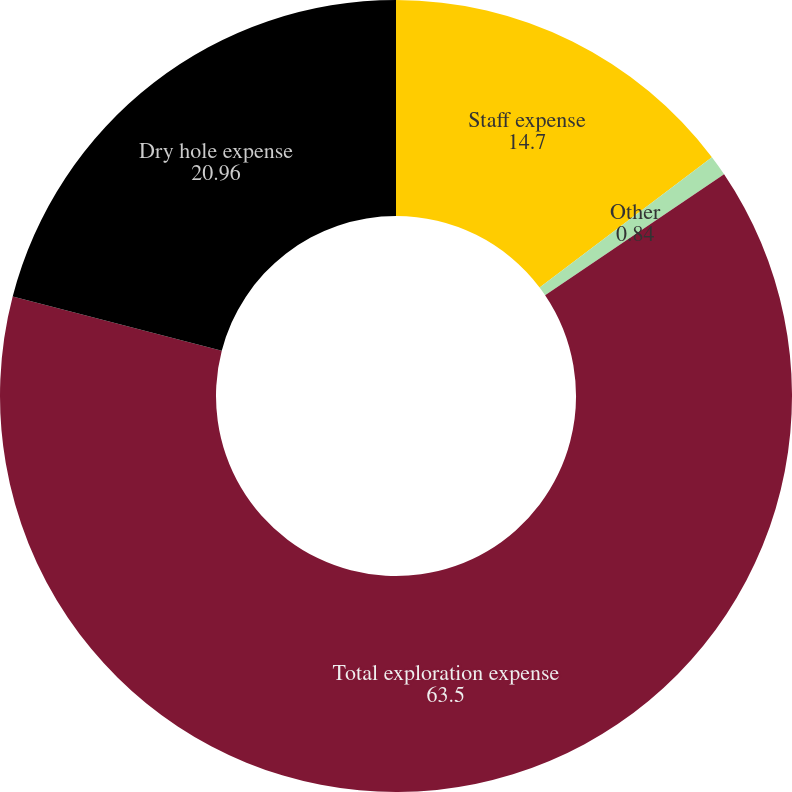Convert chart to OTSL. <chart><loc_0><loc_0><loc_500><loc_500><pie_chart><fcel>Staff expense<fcel>Other<fcel>Total exploration expense<fcel>Dry hole expense<nl><fcel>14.7%<fcel>0.84%<fcel>63.5%<fcel>20.96%<nl></chart> 